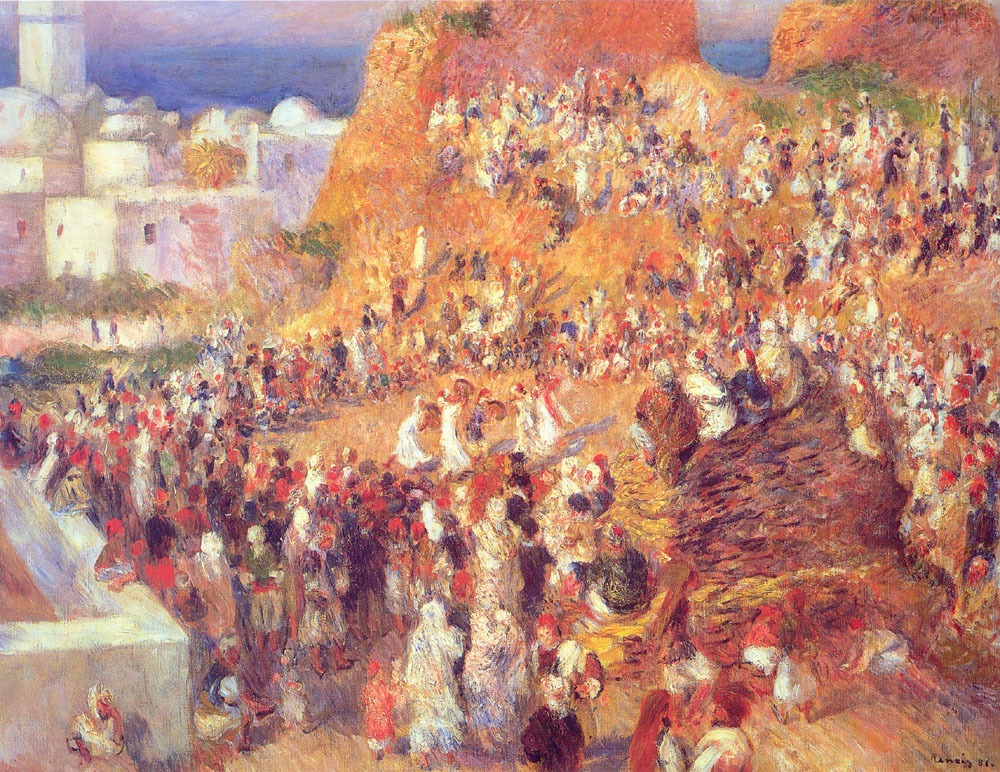What time of day does the scene in the painting represent? The painting likely depicts a scene in the late morning to early afternoon. The warm, bright colors and the way light illuminates the scene suggest a time when the sun is high in the sky, casting vibrant hues and creating dynamic shadows. The bustling activity of the market also hints at a time when the market is bustling with life and energy, typically after the morning rush. 